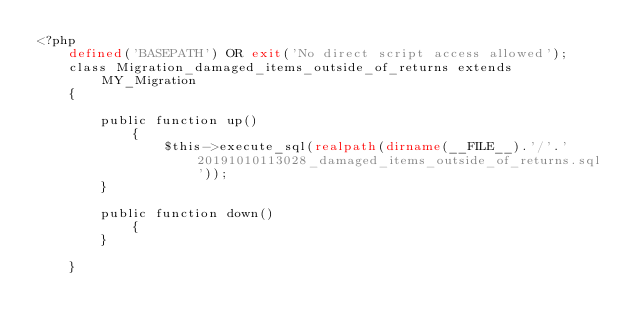<code> <loc_0><loc_0><loc_500><loc_500><_PHP_><?php
	defined('BASEPATH') OR exit('No direct script access allowed');
	class Migration_damaged_items_outside_of_returns extends MY_Migration 
	{

	    public function up() 
			{
				$this->execute_sql(realpath(dirname(__FILE__).'/'.'20191010113028_damaged_items_outside_of_returns.sql'));
	    }

	    public function down() 
			{
	    }

	}</code> 